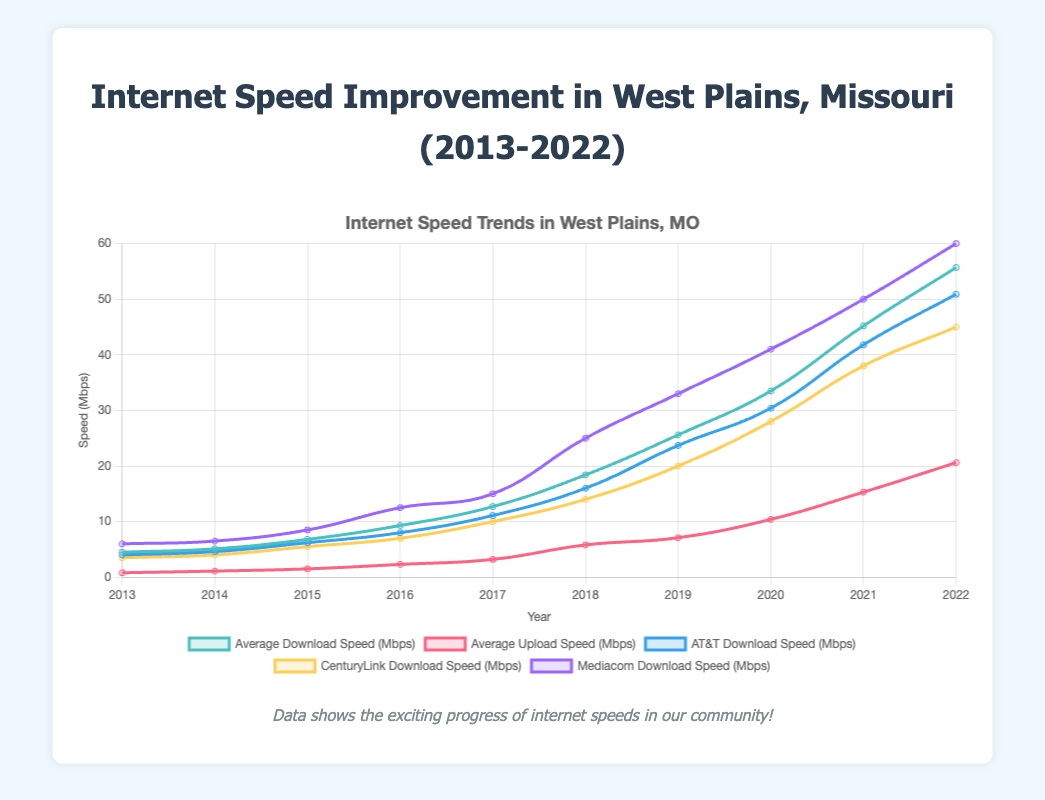What is the overall trend in average download speeds in West Plains, Missouri from 2013 to 2022? The trend line for the average download speeds shows an upward trajectory over the years from 2013 to 2022, indicating continuous improvement in download speeds.
Answer: Upward Which service provider had the highest download speed in 2022, and what was that speed? The plotted line for Mediacom shows the highest point in 2022 for download speed among the service providers, reaching 60 Mbps.
Answer: Mediacom, 60 Mbps By how much did the average upload speed increase from 2013 to 2022? In 2013, the average upload speed was 0.8 Mbps, and in 2022 it was 20.6 Mbps. The difference is 20.6 - 0.8 = 19.8 Mbps.
Answer: 19.8 Mbps Which year showed the biggest leap in average download speeds? The steepest increase appears from 2017 to 2018, with the average download speed increasing from 12.7 Mbps to 18.4 Mbps. The difference is 18.4 - 12.7 = 5.7 Mbps.
Answer: 2017 to 2018 Between AT&T and CenturyLink, which provider had a greater increase in download speed from 2014 to 2016? AT&T's download speed increased from 4.6 Mbps in 2014 to 8.0 Mbps in 2016, an increase of 3.4 Mbps. CenturyLink's download speed increased from 4.0 Mbps in 2014 to 7.0 Mbps in 2016, an increase of 3.0 Mbps. Thus, AT&T had a greater increase.
Answer: AT&T How does the download speed trend for Mediacom compare to the average download speed trend over the years? Both Mediacom and the average download speed trends show an upward trajectory, but Mediacom consistently sits above the average download speeds, suggesting it offers higher-than-average service.
Answer: Mediacom trend is higher What was the average download and upload speed in the midpoint year, 2017? In 2017, the plotted points for average download and upload speeds are around 12.7 Mbps and 3.2 Mbps respectively.
Answer: Download: 12.7 Mbps, Upload: 3.2 Mbps Which provider had the lowest upload speed in 2015, and what was that speed? By observing the lowest point in the upload speeds for 2015, CenturyLink had the lowest upload speed at 1.2 Mbps.
Answer: CenturyLink, 1.2 Mbps In what years did the average upload speed double? Starting from 0.8 Mbps in 2013, it doubled by 2015 to around 1.6 Mbps, and again from around 2.3 Mbps in 2016, it doubled by 2018 to 5.8 Mbps. Then from 5.8 Mbps in 2018, it doubled by 2022 to 20.6 Mbps.
Answer: 2015, 2018, 2022 Compare the average download speed in 2020 with the sum of AT&T and CenturyLink's download speeds in 2019. The average download speed in 2020 was 33.5 Mbps. AT&T and CenturyLink download speeds in 2019 were 23.7 Mbps and 20.0 Mbps respectively. The sum of these speeds is 23.7 + 20.0 = 43.7 Mbps, which is higher than the average download speed in 2020.
Answer: 33.5 Mbps vs. 43.7 Mbps 